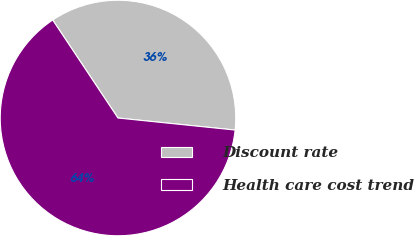Convert chart to OTSL. <chart><loc_0><loc_0><loc_500><loc_500><pie_chart><fcel>Discount rate<fcel>Health care cost trend<nl><fcel>35.98%<fcel>64.02%<nl></chart> 